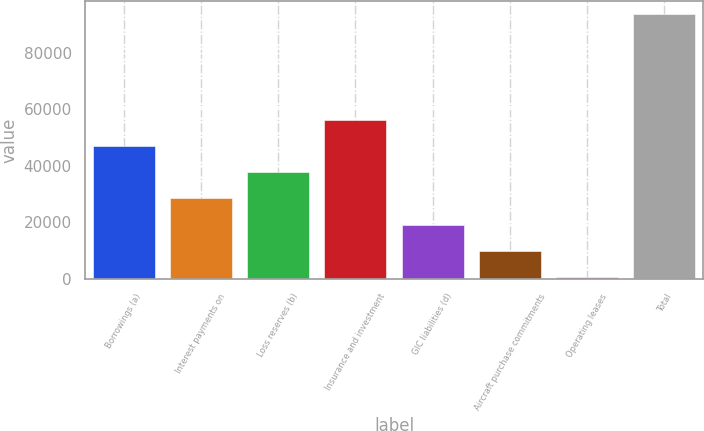Convert chart. <chart><loc_0><loc_0><loc_500><loc_500><bar_chart><fcel>Borrowings (a)<fcel>Interest payments on<fcel>Loss reserves (b)<fcel>Insurance and investment<fcel>GIC liabilities (d)<fcel>Aircraft purchase commitments<fcel>Operating leases<fcel>Total<nl><fcel>47055<fcel>28465.4<fcel>37760.2<fcel>56349.8<fcel>19170.6<fcel>9875.8<fcel>581<fcel>93529<nl></chart> 